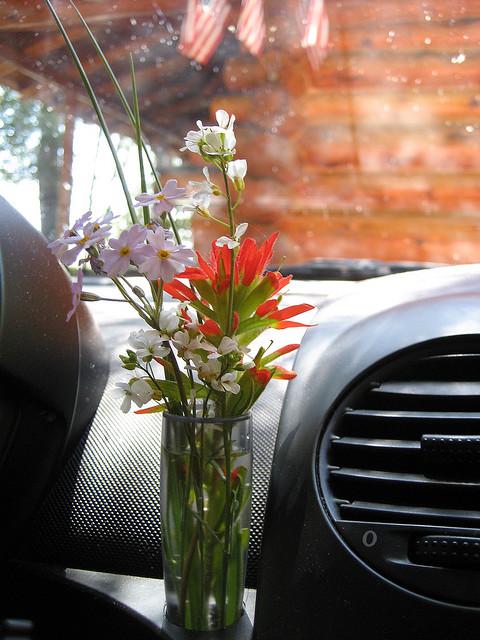What type of flower is this?
Short answer required. Daisy. Is the vase on a table?
Concise answer only. No. What is behind the flowers?
Be succinct. Dashboard. 